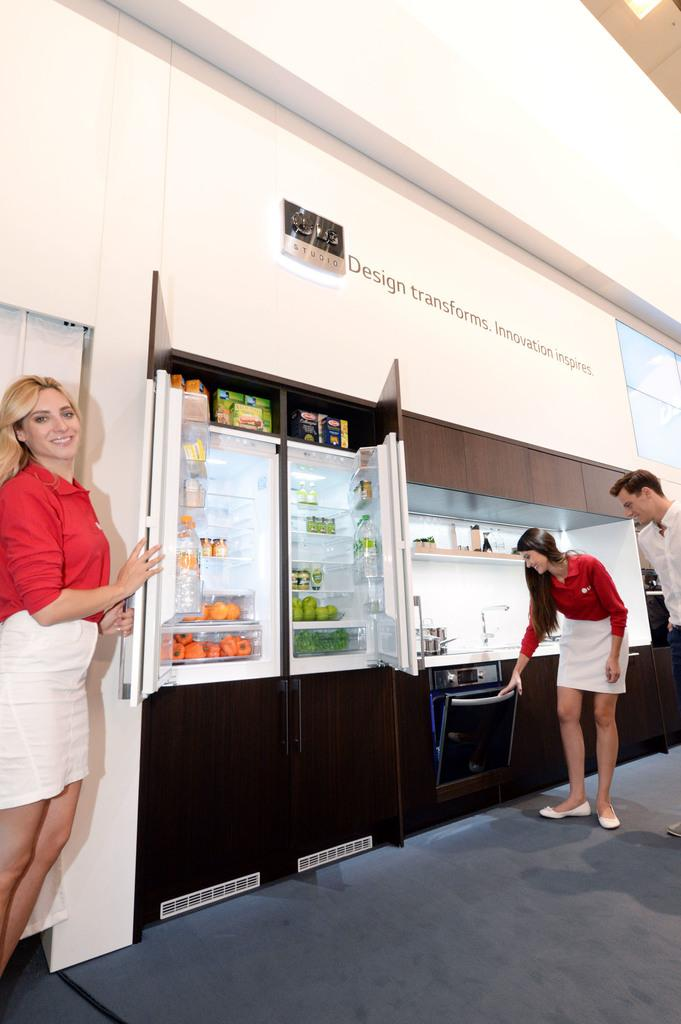<image>
Relay a brief, clear account of the picture shown. A woman stands below a wall that states, "Design transforms." 